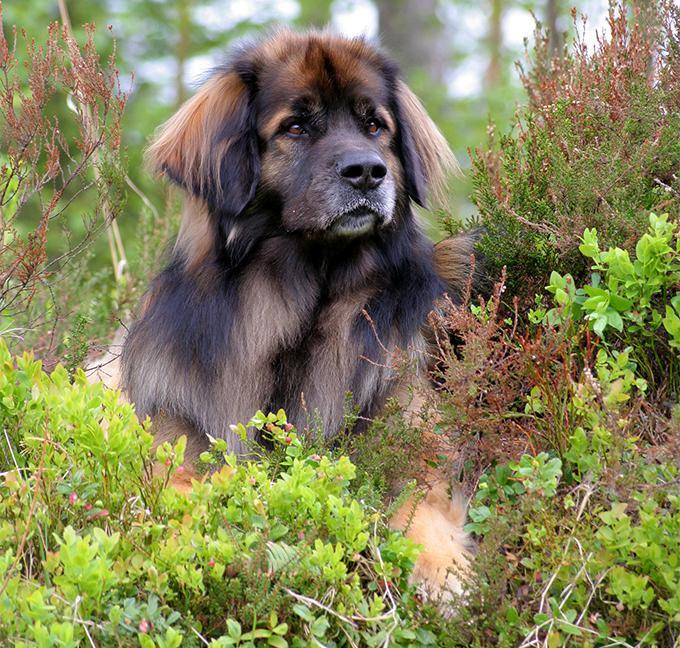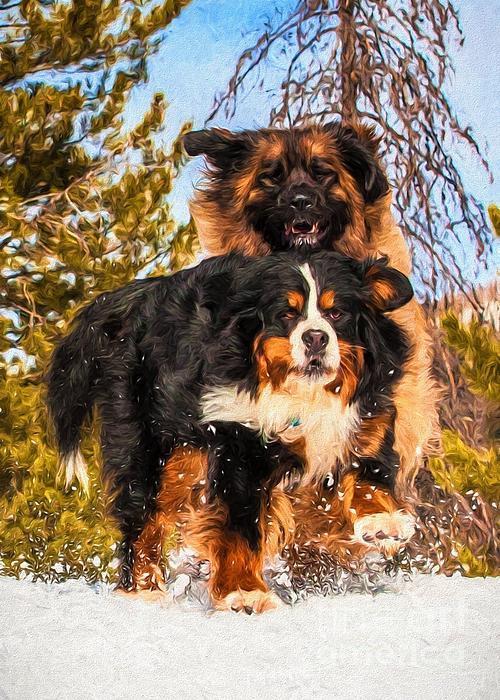The first image is the image on the left, the second image is the image on the right. For the images shown, is this caption "There are three dogs" true? Answer yes or no. Yes. 